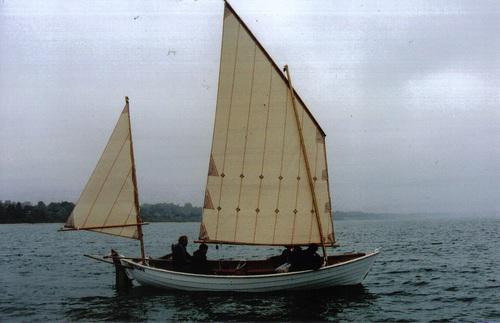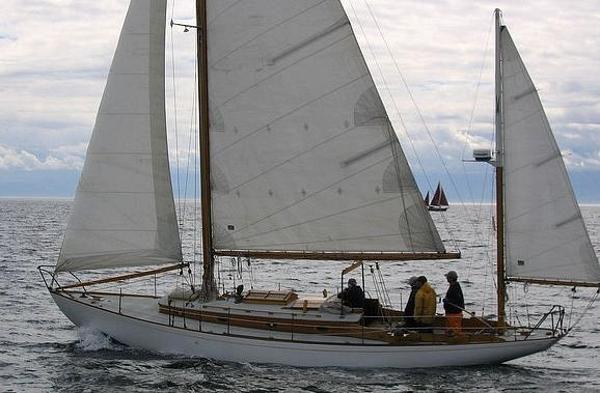The first image is the image on the left, the second image is the image on the right. For the images displayed, is the sentence "There is a sailboat with only two distinct sails." factually correct? Answer yes or no. Yes. 